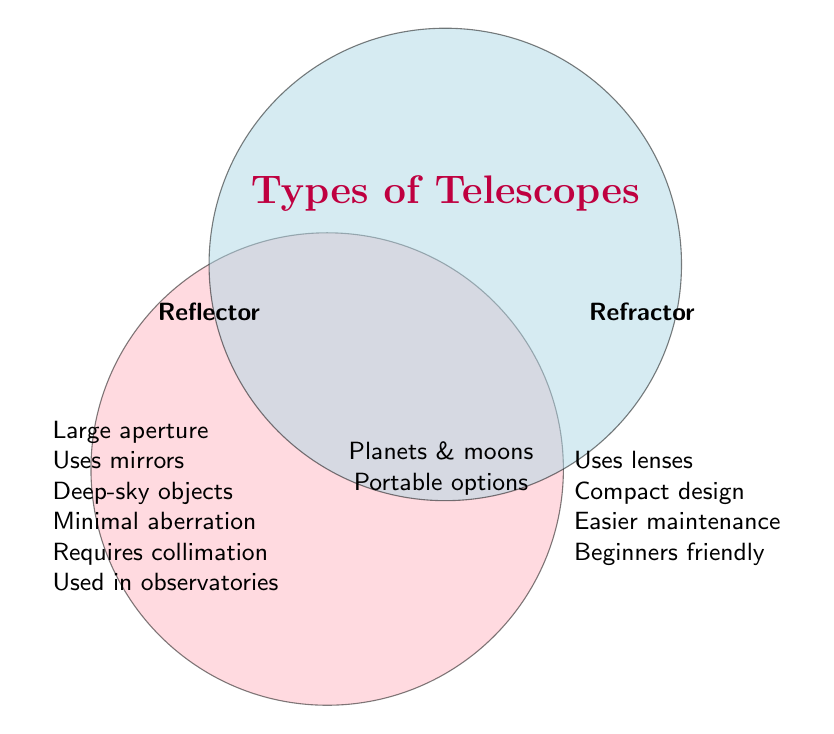What are the titles of the two telescope types represented in the Venn diagram? Look at the labels placed in different regions of the circles. The titles are clearly displayed in bold font.
Answer: Reflector and Refractor Which type of telescope uses mirrors? The information for Reflector telescopes includes "Uses mirrors," as seen on the left side of the Venn diagram.
Answer: Reflector Name one feature exclusive to Refractor telescopes. In the section labeled "Refractor," one feature listed is "Uses lenses."
Answer: Uses lenses What common features are shared by both types of telescopes? In the overlapping area of the two circles, the features listed are "Can view planets and moons" and "Portable options available."
Answer: Can view planets and moons and Portable options available Which telescope is noted for being easier to maintain? The section labeled "Refractor" includes "Easier maintenance."
Answer: Refractor Which type of telescope tends to be used in observatories? "Used in many observatories" is noted in the section for Reflector telescopes.
Answer: Reflector Compare the suitability of each telescope type for beginners. The Refractor section includes "Suitable for beginners," while the Reflector section has no such note. Therefore, Refractor is more suitable for beginners.
Answer: Refractor If you want a telescope for deep-sky objects, which one should you choose? The feature "Good for deep-sky objects" is listed only under Reflector.
Answer: Reflector Which telescope type requires collimation? The Reflector section explicitly mentions "Requires collimation."
Answer: Reflector Which type of telescope has a compact design? "Compact design" is listed in the Refractor section.
Answer: Refractor 